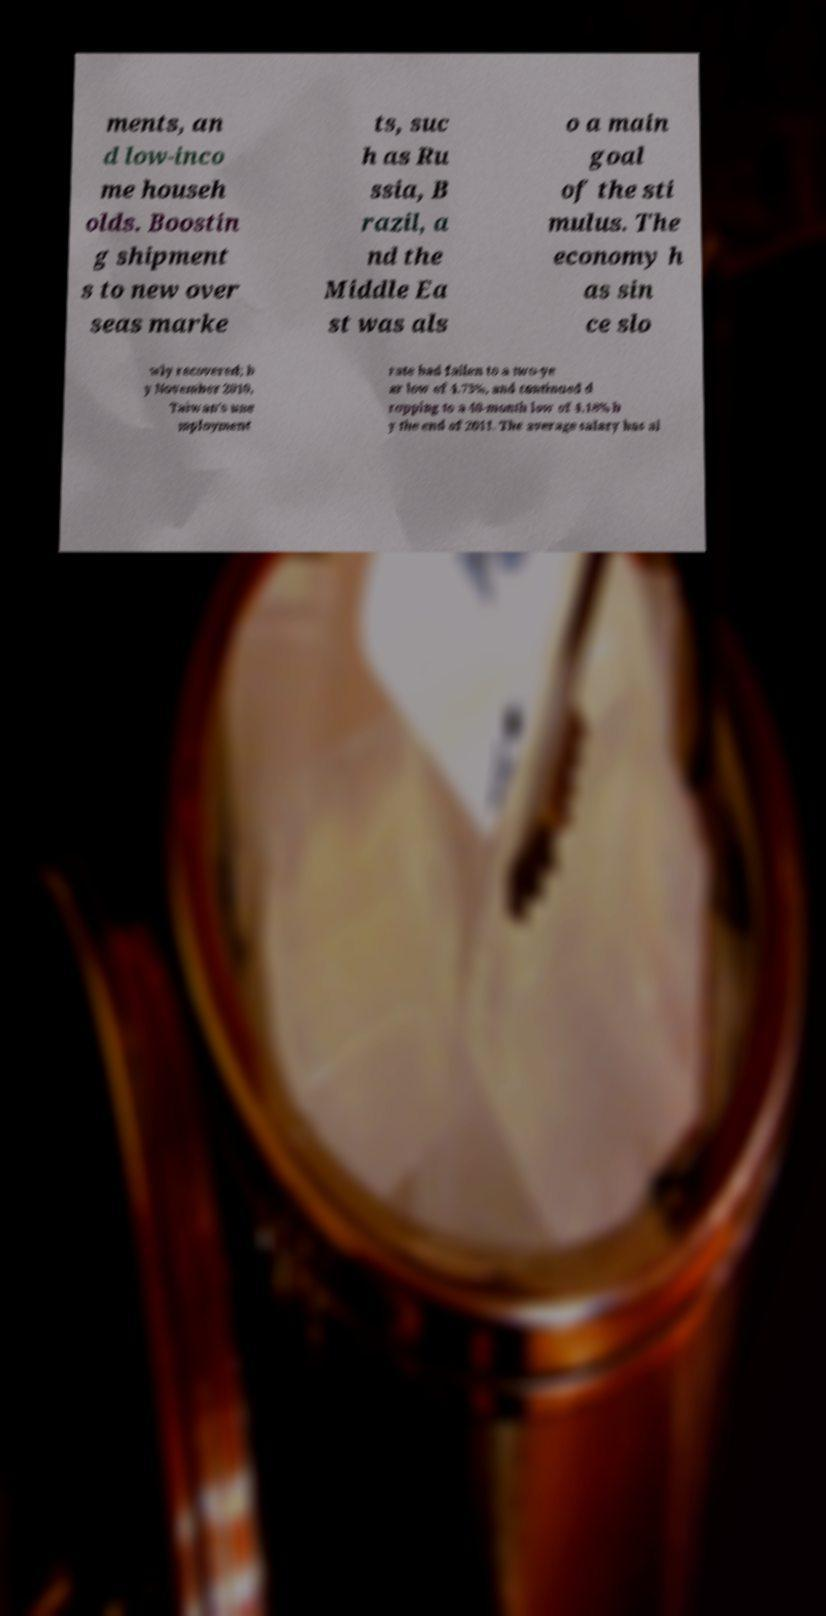Please identify and transcribe the text found in this image. ments, an d low-inco me househ olds. Boostin g shipment s to new over seas marke ts, suc h as Ru ssia, B razil, a nd the Middle Ea st was als o a main goal of the sti mulus. The economy h as sin ce slo wly recovered; b y November 2010, Taiwan's une mployment rate had fallen to a two-ye ar low of 4.73%, and continued d ropping to a 40-month low of 4.18% b y the end of 2011. The average salary has al 